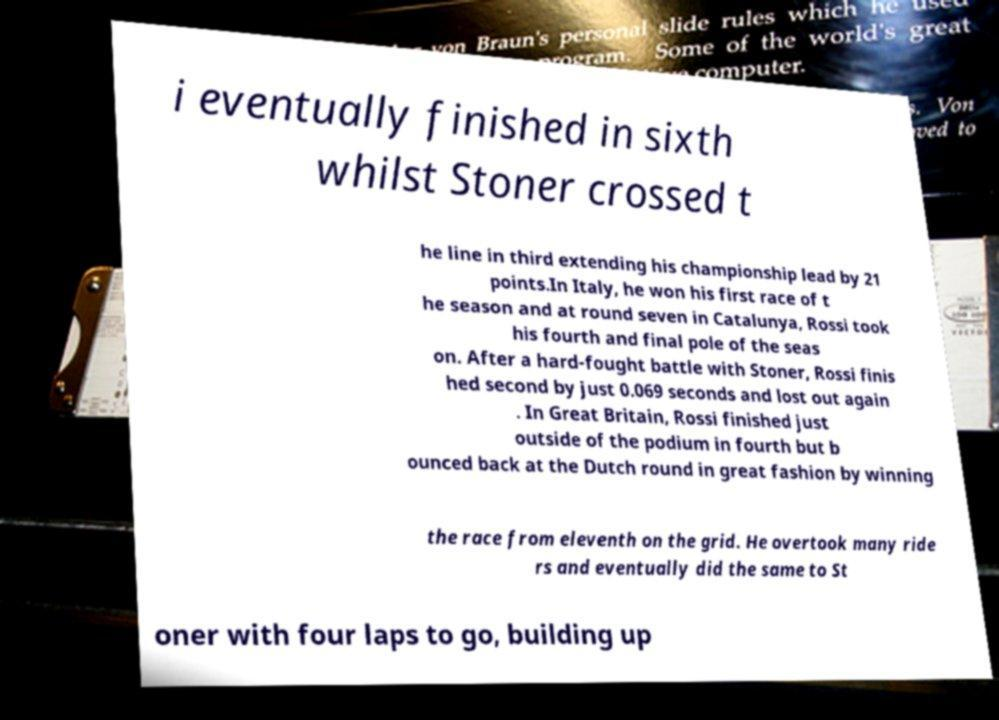Please read and relay the text visible in this image. What does it say? i eventually finished in sixth whilst Stoner crossed t he line in third extending his championship lead by 21 points.In Italy, he won his first race of t he season and at round seven in Catalunya, Rossi took his fourth and final pole of the seas on. After a hard-fought battle with Stoner, Rossi finis hed second by just 0.069 seconds and lost out again . In Great Britain, Rossi finished just outside of the podium in fourth but b ounced back at the Dutch round in great fashion by winning the race from eleventh on the grid. He overtook many ride rs and eventually did the same to St oner with four laps to go, building up 